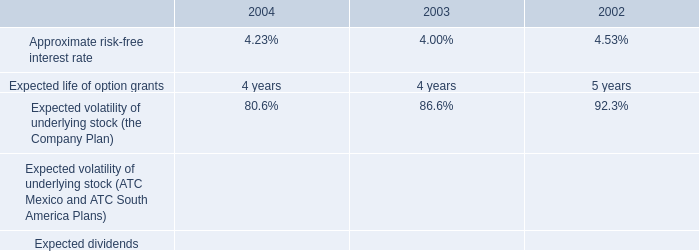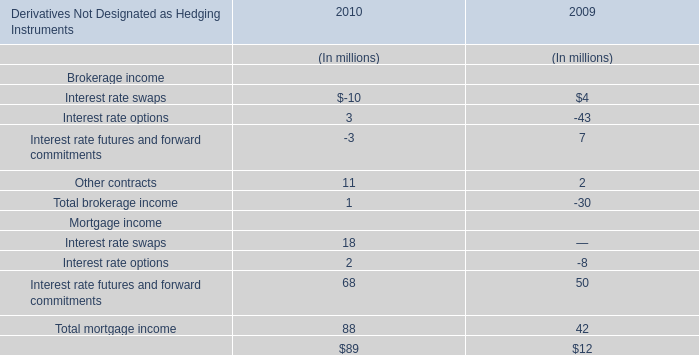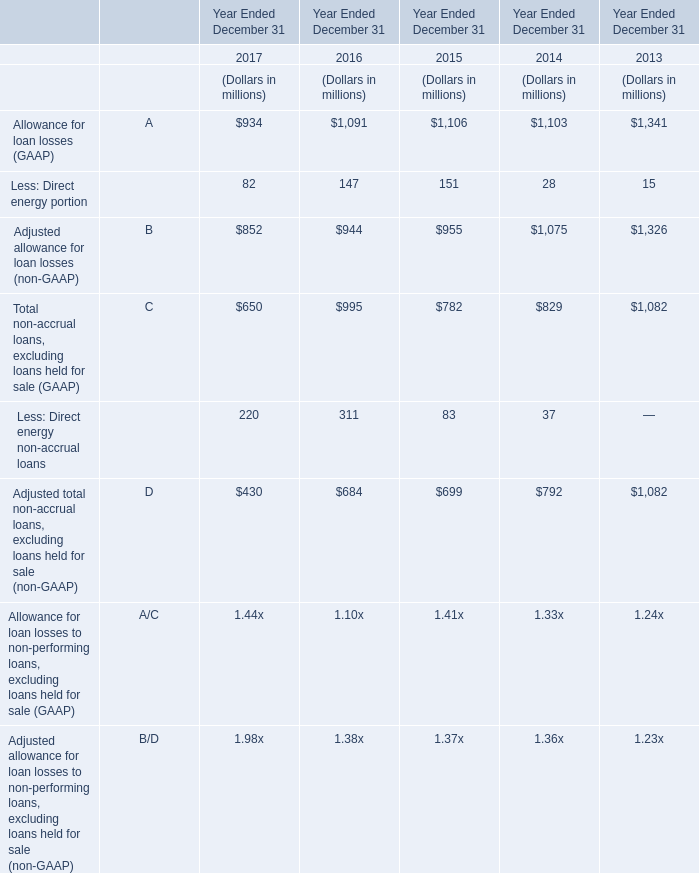based on the black-scholes option pricing model what was the percent of the change in the option prices from 2003 to 2004 
Computations: ((7.05 / 6.32) / 6.32)
Answer: 0.1765. 